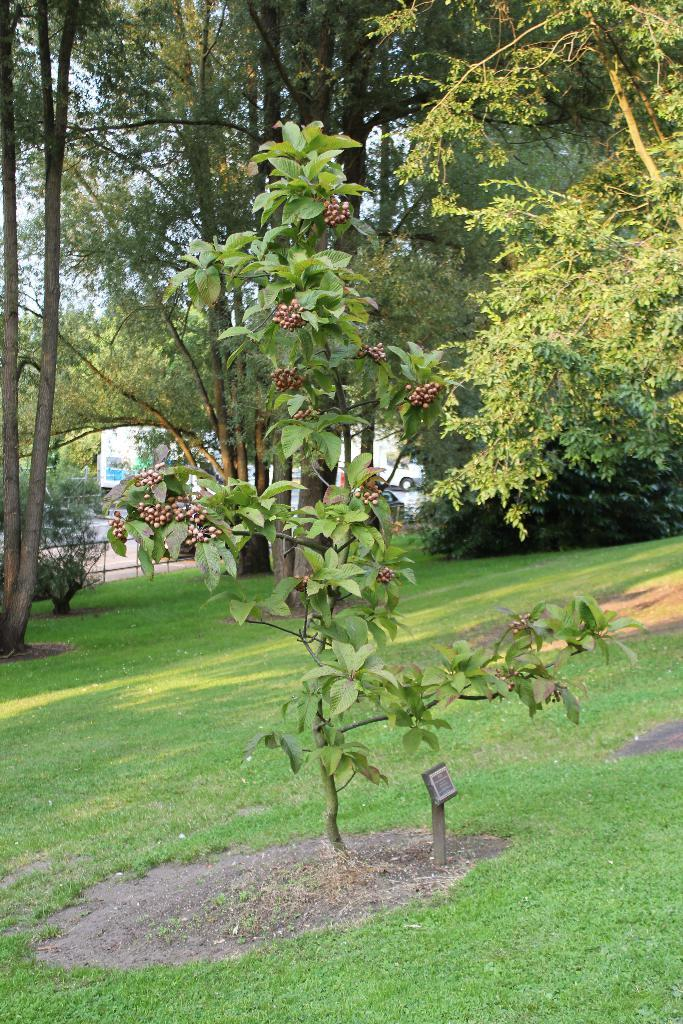What type of living organism can be seen in the image? There is a plant in the image. What can be seen in the background of the image? There are trees in the background of the image. What is visible at the bottom of the image? The ground is visible at the bottom of the image. What type of party is being held in the image? There is no party present in the image; it features a plant, trees in the background, and the ground. What is the head of the plant doing in the image? There is no head of the plant visible in the image, as plants do not have heads. 